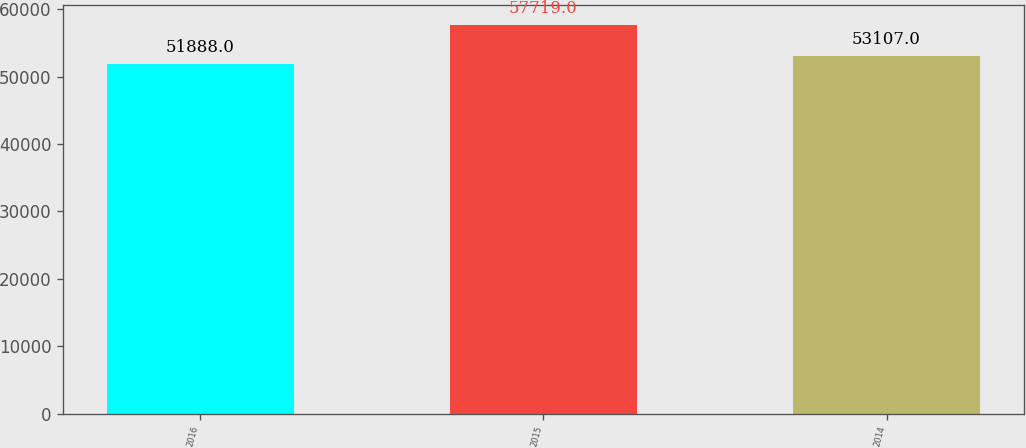Convert chart. <chart><loc_0><loc_0><loc_500><loc_500><bar_chart><fcel>2016<fcel>2015<fcel>2014<nl><fcel>51888<fcel>57719<fcel>53107<nl></chart> 